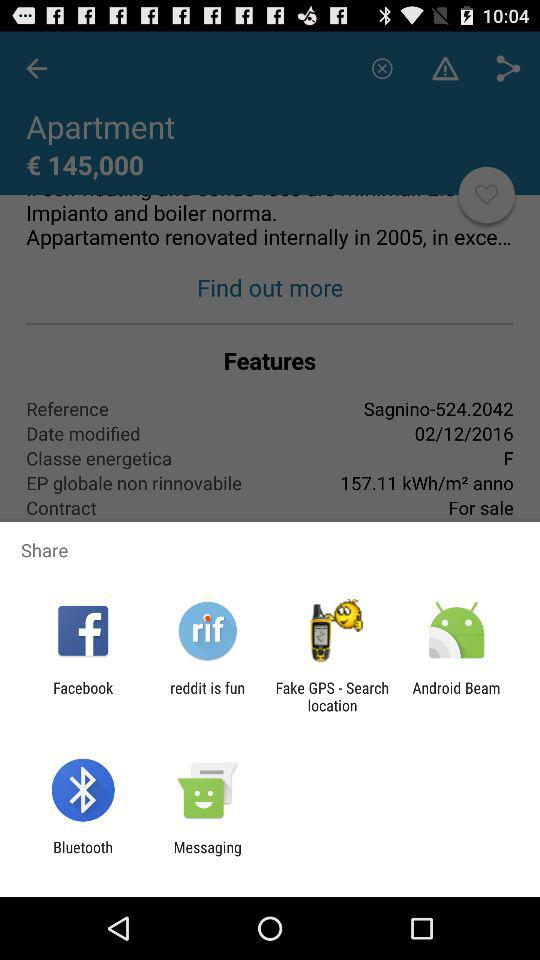In which year was the apartment renovated internally? The year was 2005. 